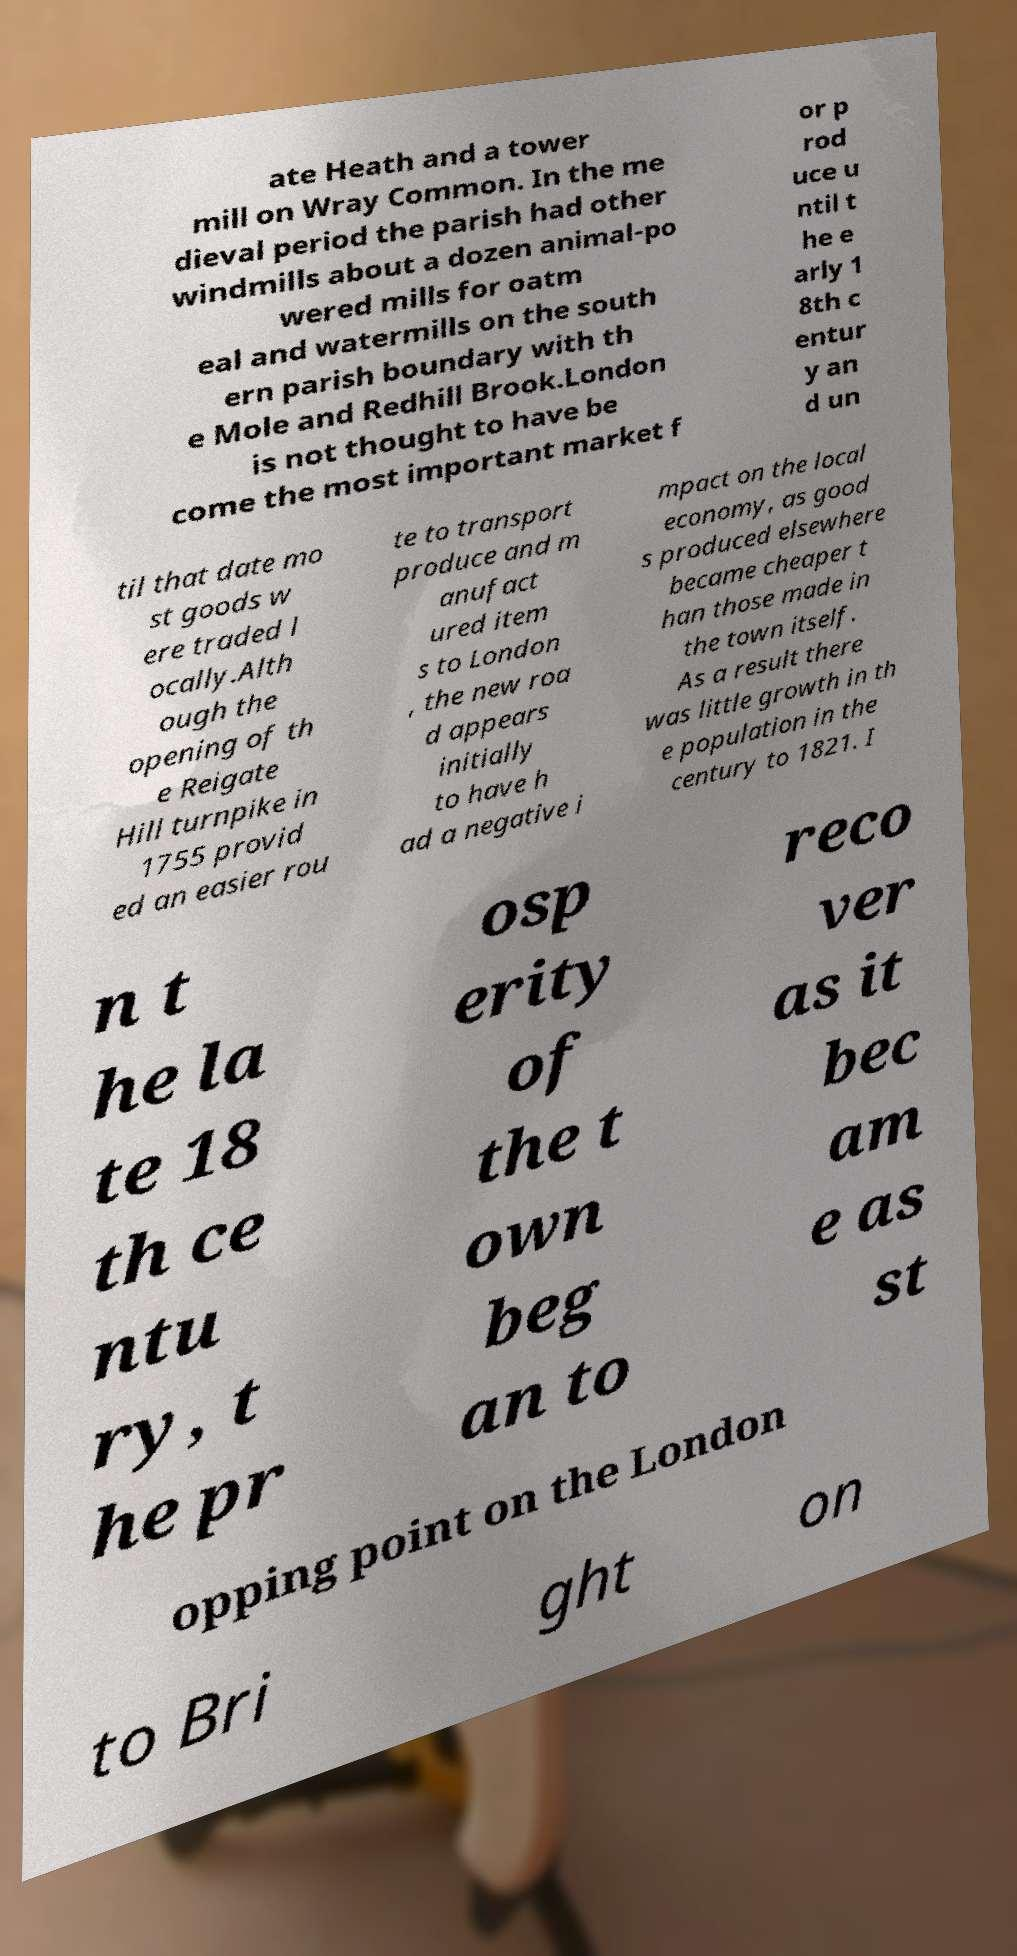I need the written content from this picture converted into text. Can you do that? ate Heath and a tower mill on Wray Common. In the me dieval period the parish had other windmills about a dozen animal-po wered mills for oatm eal and watermills on the south ern parish boundary with th e Mole and Redhill Brook.London is not thought to have be come the most important market f or p rod uce u ntil t he e arly 1 8th c entur y an d un til that date mo st goods w ere traded l ocally.Alth ough the opening of th e Reigate Hill turnpike in 1755 provid ed an easier rou te to transport produce and m anufact ured item s to London , the new roa d appears initially to have h ad a negative i mpact on the local economy, as good s produced elsewhere became cheaper t han those made in the town itself. As a result there was little growth in th e population in the century to 1821. I n t he la te 18 th ce ntu ry, t he pr osp erity of the t own beg an to reco ver as it bec am e as st opping point on the London to Bri ght on 